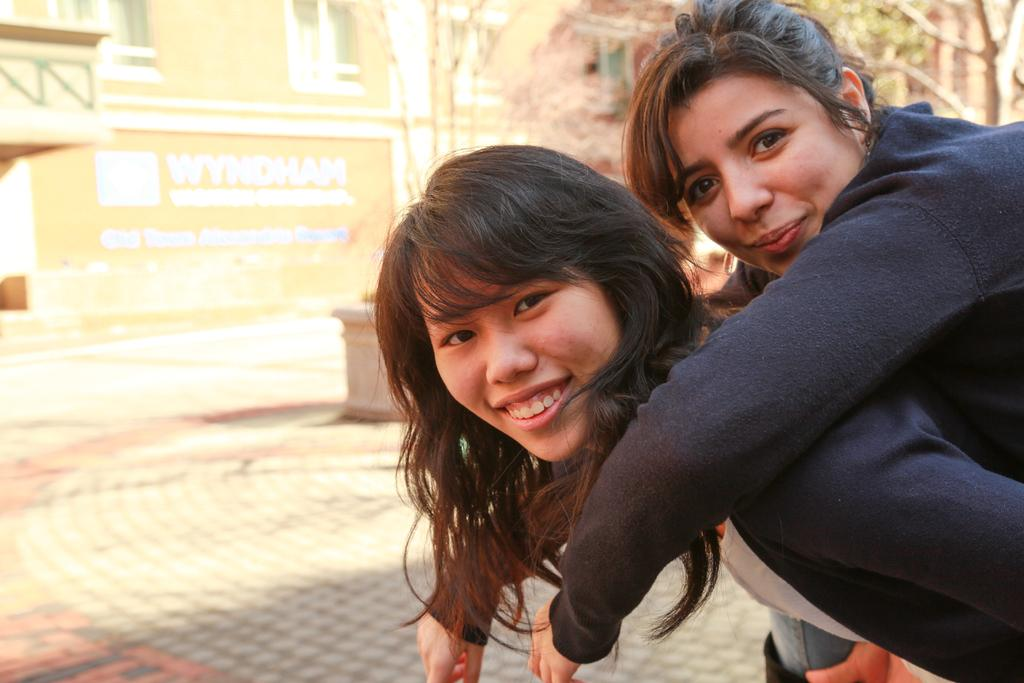How many women are in the image? There are two women in the image. Where are the women located in the image? The women are on the left side of the image. What are the women wearing? The women are wearing sweatshirts. What expression do the women have? The women are smiling. What can be seen in the background of the image? There is a building and trees in the background of the image. What type of toy is the women playing with in the image? There is no toy present in the image; the women are simply standing and smiling. 